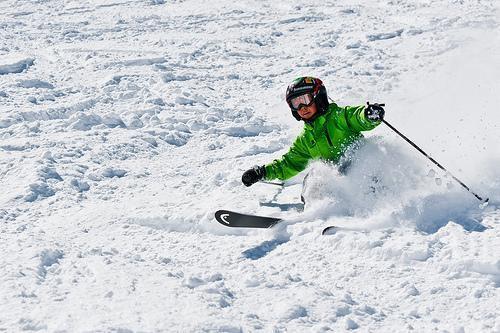How many arms does the skier have?
Give a very brief answer. 2. 